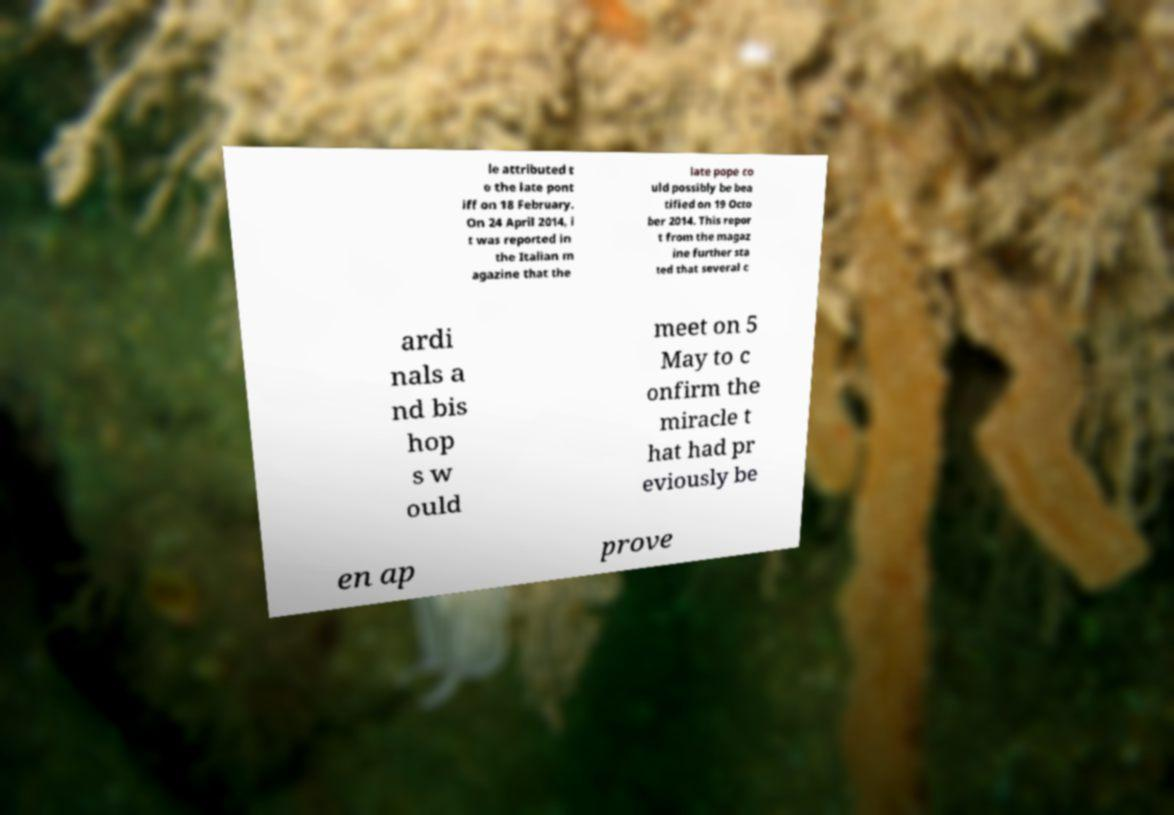What messages or text are displayed in this image? I need them in a readable, typed format. le attributed t o the late pont iff on 18 February. On 24 April 2014, i t was reported in the Italian m agazine that the late pope co uld possibly be bea tified on 19 Octo ber 2014. This repor t from the magaz ine further sta ted that several c ardi nals a nd bis hop s w ould meet on 5 May to c onfirm the miracle t hat had pr eviously be en ap prove 